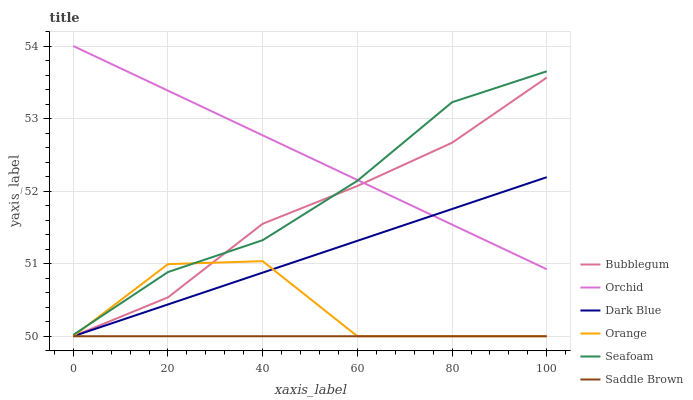Does Saddle Brown have the minimum area under the curve?
Answer yes or no. Yes. Does Orchid have the maximum area under the curve?
Answer yes or no. Yes. Does Bubblegum have the minimum area under the curve?
Answer yes or no. No. Does Bubblegum have the maximum area under the curve?
Answer yes or no. No. Is Saddle Brown the smoothest?
Answer yes or no. Yes. Is Orange the roughest?
Answer yes or no. Yes. Is Bubblegum the smoothest?
Answer yes or no. No. Is Bubblegum the roughest?
Answer yes or no. No. Does Bubblegum have the lowest value?
Answer yes or no. Yes. Does Orchid have the lowest value?
Answer yes or no. No. Does Orchid have the highest value?
Answer yes or no. Yes. Does Bubblegum have the highest value?
Answer yes or no. No. Is Saddle Brown less than Seafoam?
Answer yes or no. Yes. Is Orchid greater than Saddle Brown?
Answer yes or no. Yes. Does Bubblegum intersect Dark Blue?
Answer yes or no. Yes. Is Bubblegum less than Dark Blue?
Answer yes or no. No. Is Bubblegum greater than Dark Blue?
Answer yes or no. No. Does Saddle Brown intersect Seafoam?
Answer yes or no. No. 